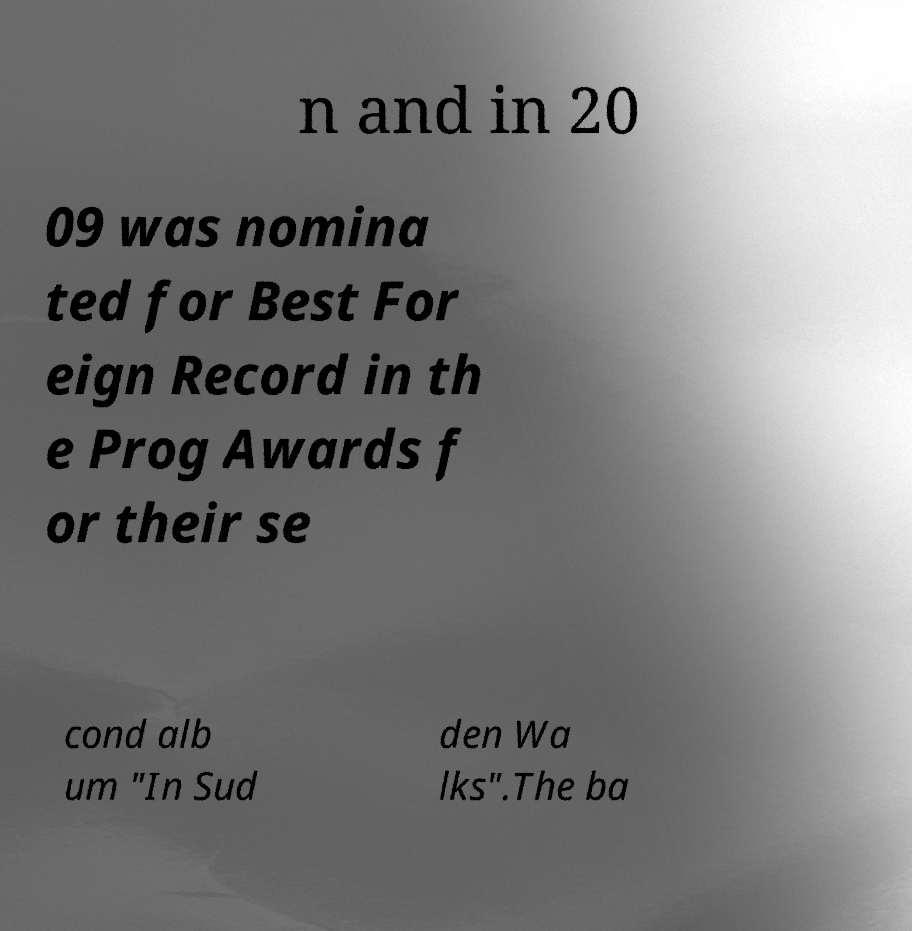Could you extract and type out the text from this image? n and in 20 09 was nomina ted for Best For eign Record in th e Prog Awards f or their se cond alb um "In Sud den Wa lks".The ba 